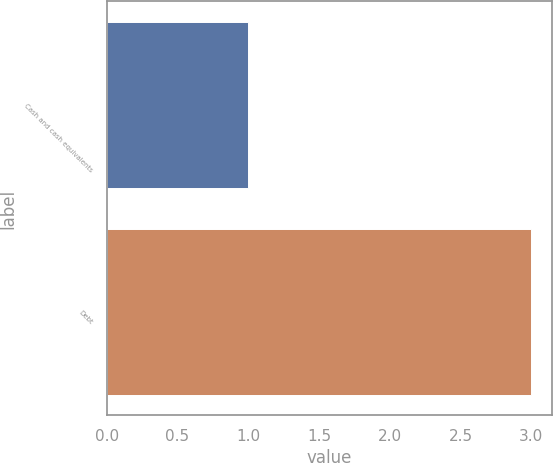<chart> <loc_0><loc_0><loc_500><loc_500><bar_chart><fcel>Cash and cash equivalents<fcel>Debt<nl><fcel>1<fcel>3<nl></chart> 